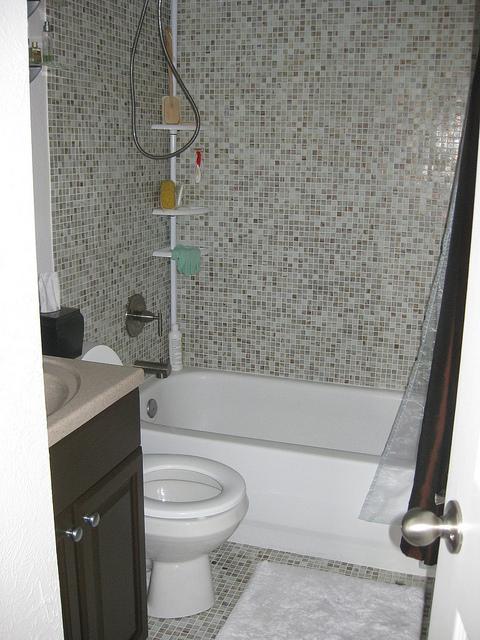Is this a bathroom?
Answer briefly. Yes. What are the shower walls made of?
Concise answer only. Tile. What color is the bathmat?
Write a very short answer. White. What is in the rack?
Be succinct. Soap. 